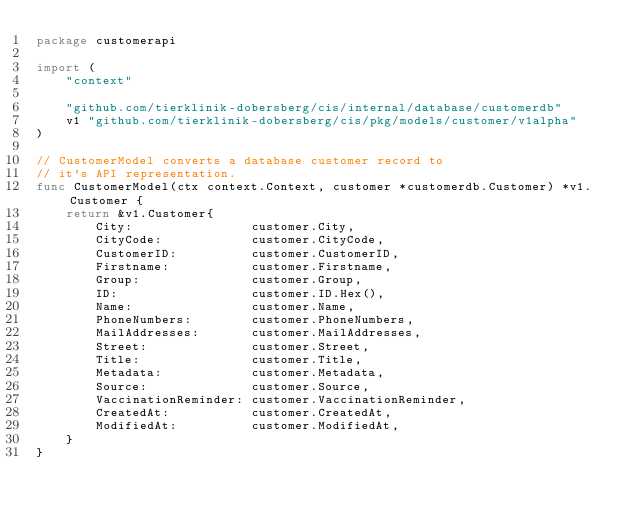<code> <loc_0><loc_0><loc_500><loc_500><_Go_>package customerapi

import (
	"context"

	"github.com/tierklinik-dobersberg/cis/internal/database/customerdb"
	v1 "github.com/tierklinik-dobersberg/cis/pkg/models/customer/v1alpha"
)

// CustomerModel converts a database customer record to
// it's API representation.
func CustomerModel(ctx context.Context, customer *customerdb.Customer) *v1.Customer {
	return &v1.Customer{
		City:                customer.City,
		CityCode:            customer.CityCode,
		CustomerID:          customer.CustomerID,
		Firstname:           customer.Firstname,
		Group:               customer.Group,
		ID:                  customer.ID.Hex(),
		Name:                customer.Name,
		PhoneNumbers:        customer.PhoneNumbers,
		MailAddresses:       customer.MailAddresses,
		Street:              customer.Street,
		Title:               customer.Title,
		Metadata:            customer.Metadata,
		Source:              customer.Source,
		VaccinationReminder: customer.VaccinationReminder,
		CreatedAt:           customer.CreatedAt,
		ModifiedAt:          customer.ModifiedAt,
	}
}
</code> 